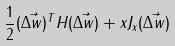Convert formula to latex. <formula><loc_0><loc_0><loc_500><loc_500>\frac { 1 } { 2 } ( \vec { \Delta w } ) ^ { T } H ( \vec { \Delta w } ) + x J _ { x } ( \vec { \Delta w } )</formula> 